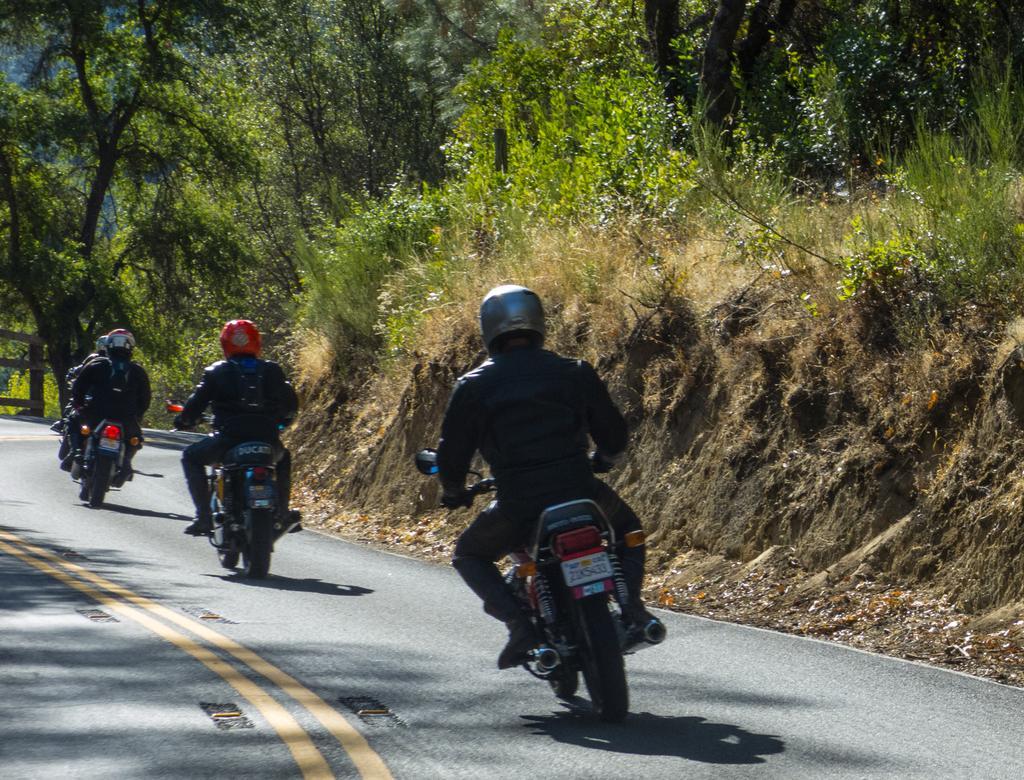Describe this image in one or two sentences. In this image I can see vehicles on road. I can also see people sitting on vehicles and wearing helmets. In the background I can see trees and the grass. 